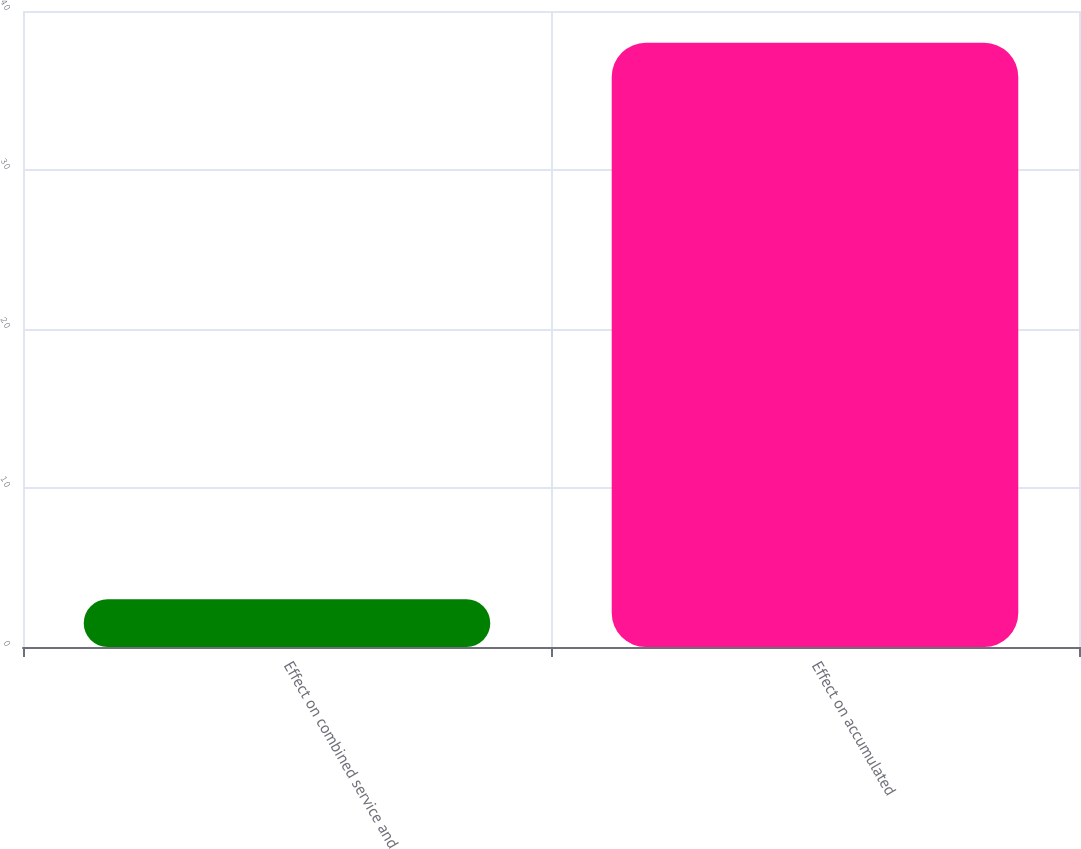Convert chart to OTSL. <chart><loc_0><loc_0><loc_500><loc_500><bar_chart><fcel>Effect on combined service and<fcel>Effect on accumulated<nl><fcel>3<fcel>38<nl></chart> 